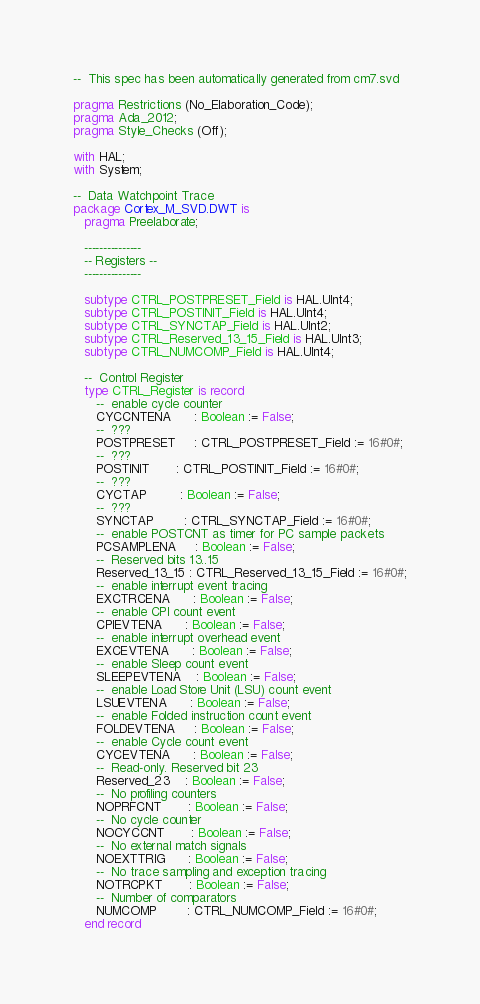<code> <loc_0><loc_0><loc_500><loc_500><_Ada_>--  This spec has been automatically generated from cm7.svd

pragma Restrictions (No_Elaboration_Code);
pragma Ada_2012;
pragma Style_Checks (Off);

with HAL;
with System;

--  Data Watchpoint Trace
package Cortex_M_SVD.DWT is
   pragma Preelaborate;

   ---------------
   -- Registers --
   ---------------

   subtype CTRL_POSTPRESET_Field is HAL.UInt4;
   subtype CTRL_POSTINIT_Field is HAL.UInt4;
   subtype CTRL_SYNCTAP_Field is HAL.UInt2;
   subtype CTRL_Reserved_13_15_Field is HAL.UInt3;
   subtype CTRL_NUMCOMP_Field is HAL.UInt4;

   --  Control Register
   type CTRL_Register is record
      --  enable cycle counter
      CYCCNTENA      : Boolean := False;
      --  ???
      POSTPRESET     : CTRL_POSTPRESET_Field := 16#0#;
      --  ???
      POSTINIT       : CTRL_POSTINIT_Field := 16#0#;
      --  ???
      CYCTAP         : Boolean := False;
      --  ???
      SYNCTAP        : CTRL_SYNCTAP_Field := 16#0#;
      --  enable POSTCNT as timer for PC sample packets
      PCSAMPLENA     : Boolean := False;
      --  Reserved bits 13..15
      Reserved_13_15 : CTRL_Reserved_13_15_Field := 16#0#;
      --  enable interrupt event tracing
      EXCTRCENA      : Boolean := False;
      --  enable CPI count event
      CPIEVTENA      : Boolean := False;
      --  enable interrupt overhead event
      EXCEVTENA      : Boolean := False;
      --  enable Sleep count event
      SLEEPEVTENA    : Boolean := False;
      --  enable Load Store Unit (LSU) count event
      LSUEVTENA      : Boolean := False;
      --  enable Folded instruction count event
      FOLDEVTENA     : Boolean := False;
      --  enable Cycle count event
      CYCEVTENA      : Boolean := False;
      --  Read-only. Reserved bit 23
      Reserved_23    : Boolean := False;
      --  No profiling counters
      NOPRFCNT       : Boolean := False;
      --  No cycle counter
      NOCYCCNT       : Boolean := False;
      --  No external match signals
      NOEXTTRIG      : Boolean := False;
      --  No trace sampling and exception tracing
      NOTRCPKT       : Boolean := False;
      --  Number of comparators
      NUMCOMP        : CTRL_NUMCOMP_Field := 16#0#;
   end record</code> 